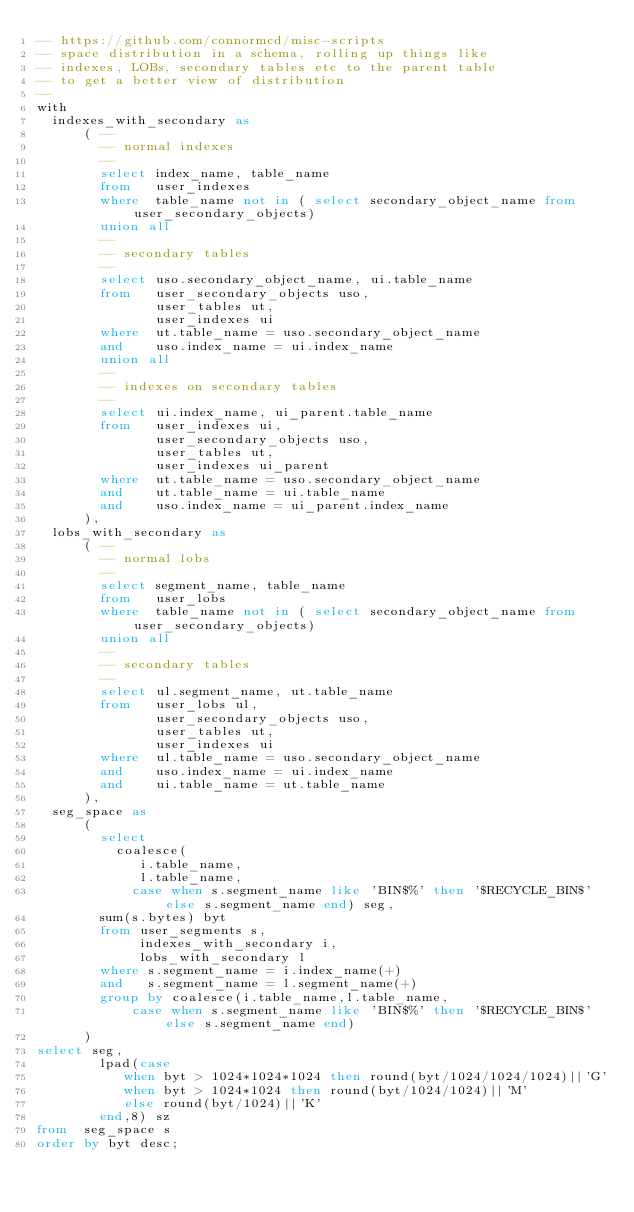Convert code to text. <code><loc_0><loc_0><loc_500><loc_500><_SQL_>-- https://github.com/connormcd/misc-scripts
-- space distribution in a schema, rolling up things like
-- indexes, LOBs, secondary tables etc to the parent table
-- to get a better view of distribution
--
with 
  indexes_with_secondary as
      ( --
        -- normal indexes
        --
        select index_name, table_name
        from   user_indexes
        where  table_name not in ( select secondary_object_name from user_secondary_objects)
        union all
        --
        -- secondary tables
        --
        select uso.secondary_object_name, ui.table_name
        from   user_secondary_objects uso,
               user_tables ut,
               user_indexes ui
        where  ut.table_name = uso.secondary_object_name
        and    uso.index_name = ui.index_name
        union all
        --
        -- indexes on secondary tables
        --
        select ui.index_name, ui_parent.table_name
        from   user_indexes ui,
               user_secondary_objects uso,
               user_tables ut,
               user_indexes ui_parent
        where  ut.table_name = uso.secondary_object_name
        and    ut.table_name = ui.table_name
        and    uso.index_name = ui_parent.index_name
      ),  
  lobs_with_secondary as
      ( --
        -- normal lobs
        --
        select segment_name, table_name
        from   user_lobs
        where  table_name not in ( select secondary_object_name from user_secondary_objects)
        union all
        --
        -- secondary tables
        --
        select ul.segment_name, ut.table_name
        from   user_lobs ul,
               user_secondary_objects uso,
               user_tables ut,
               user_indexes ui
        where  ul.table_name = uso.secondary_object_name
        and    uso.index_name = ui.index_name
        and    ui.table_name = ut.table_name
      ),
  seg_space as
      (
        select 
          coalesce(
             i.table_name,
             l.table_name, 
            case when s.segment_name like 'BIN$%' then '$RECYCLE_BIN$' else s.segment_name end) seg, 
        sum(s.bytes) byt
        from user_segments s,
             indexes_with_secondary i,
             lobs_with_secondary l
        where s.segment_name = i.index_name(+)
        and   s.segment_name = l.segment_name(+)     
        group by coalesce(i.table_name,l.table_name, 
            case when s.segment_name like 'BIN$%' then '$RECYCLE_BIN$' else s.segment_name end)
      )  
select seg, 
        lpad(case 
           when byt > 1024*1024*1024 then round(byt/1024/1024/1024)||'G'
           when byt > 1024*1024 then round(byt/1024/1024)||'M'
           else round(byt/1024)||'K'
        end,8) sz
from  seg_space s
order by byt desc;
</code> 